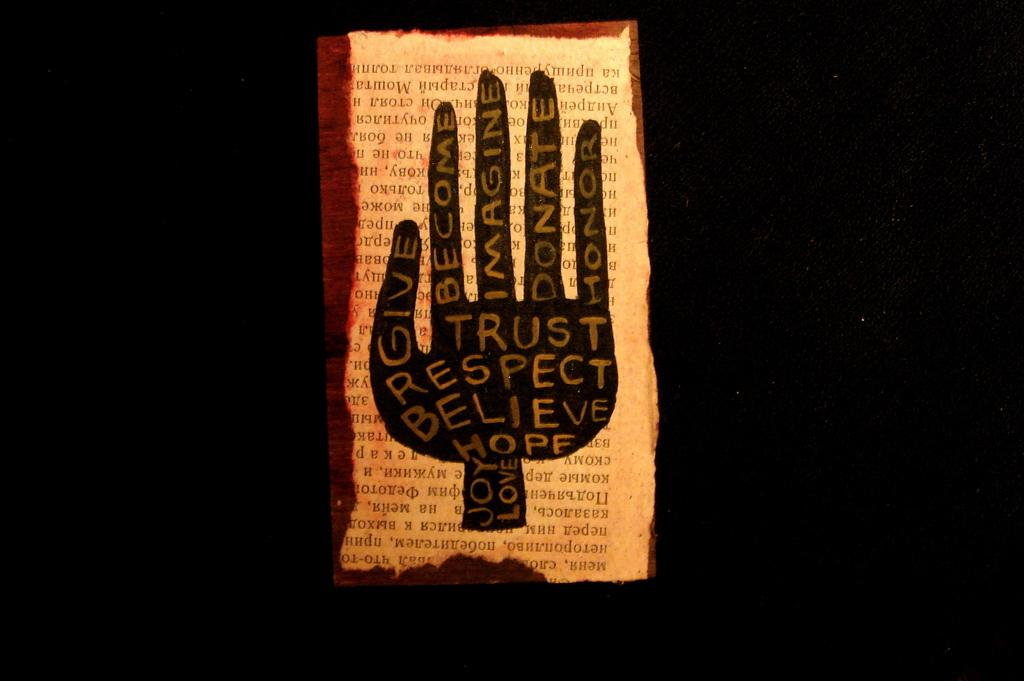<image>
Relay a brief, clear account of the picture shown. A page that has a hand with many positive words such as believe and hope 